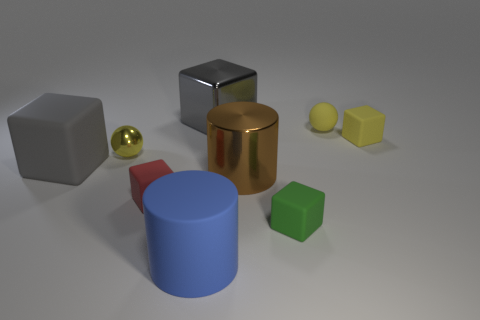Does the sphere behind the tiny metal thing have the same material as the tiny ball on the left side of the brown object? no 